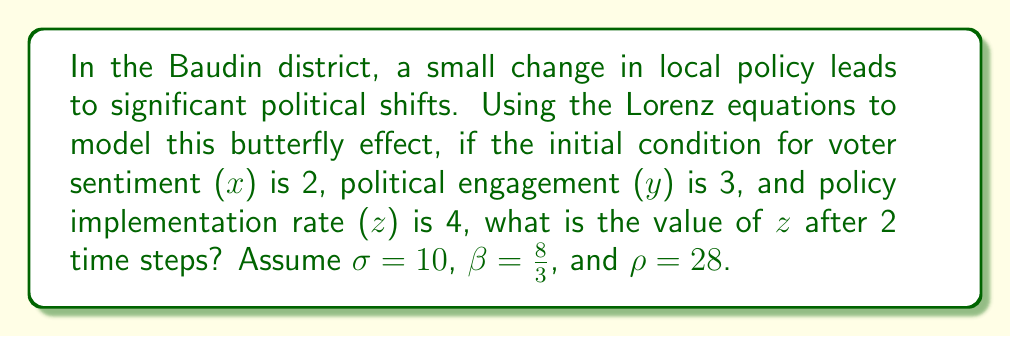Give your solution to this math problem. To solve this problem, we'll use the Lorenz equations to model the butterfly effect in the Baudin district's political system:

$$\frac{dx}{dt} = \sigma(y - x)$$
$$\frac{dy}{dt} = x(\rho - z) - y$$
$$\frac{dz}{dt} = xy - \beta z$$

Given:
- Initial conditions: x₀ = 2, y₀ = 3, z₀ = 4
- Parameters: σ = 10, β = 8/3, ρ = 28
- Time steps: 2

Step 1: Calculate the rates of change for the first time step.
$$\frac{dx}{dt} = 10(3 - 2) = 10$$
$$\frac{dy}{dt} = 2(28 - 4) - 3 = 45$$
$$\frac{dz}{dt} = 2 * 3 - \frac{8}{3} * 4 = -4\frac{2}{3}$$

Step 2: Update the values for the next time step (assuming a time step of 1).
x₁ = 2 + 10 = 12
y₁ = 3 + 45 = 48
z₁ = 4 - 4⅔ = -⅔

Step 3: Calculate the rates of change for the second time step.
$$\frac{dx}{dt} = 10(48 - 12) = 360$$
$$\frac{dy}{dt} = 12(28 + \frac{2}{3}) - 48 = 295\frac{1}{3}$$
$$\frac{dz}{dt} = 12 * 48 - \frac{8}{3} * (-\frac{2}{3}) = 577\frac{7}{9}$$

Step 4: Update the values for the final time step.
x₂ = 12 + 360 = 372
y₂ = 48 + 295⅓ = 343⅓
z₂ = -⅔ + 577⅞ = 577⅕

Therefore, after 2 time steps, the value of z (policy implementation rate) is approximately 577⅕.
Answer: 577⅕ 